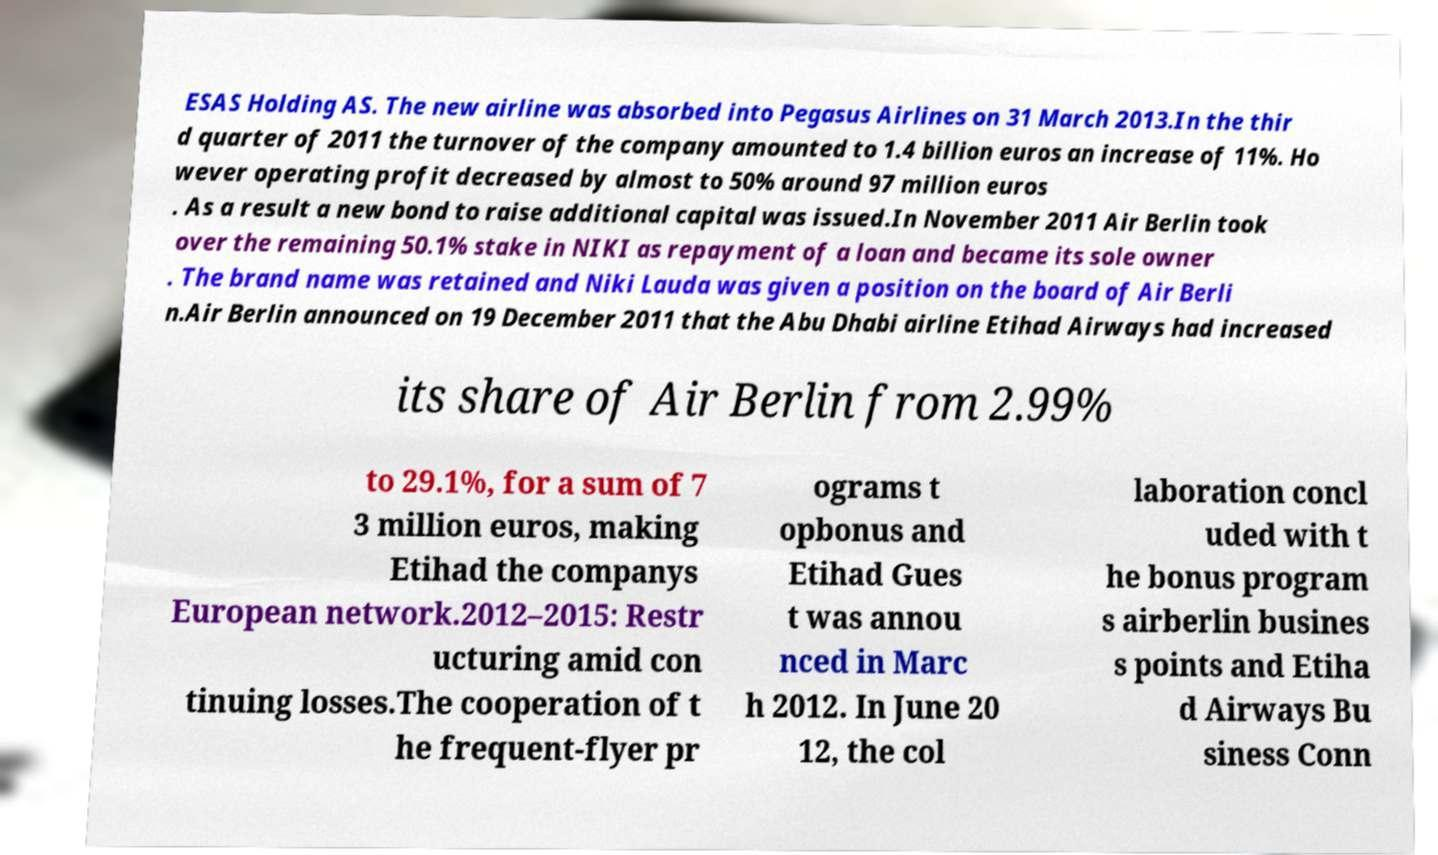For documentation purposes, I need the text within this image transcribed. Could you provide that? ESAS Holding AS. The new airline was absorbed into Pegasus Airlines on 31 March 2013.In the thir d quarter of 2011 the turnover of the company amounted to 1.4 billion euros an increase of 11%. Ho wever operating profit decreased by almost to 50% around 97 million euros . As a result a new bond to raise additional capital was issued.In November 2011 Air Berlin took over the remaining 50.1% stake in NIKI as repayment of a loan and became its sole owner . The brand name was retained and Niki Lauda was given a position on the board of Air Berli n.Air Berlin announced on 19 December 2011 that the Abu Dhabi airline Etihad Airways had increased its share of Air Berlin from 2.99% to 29.1%, for a sum of 7 3 million euros, making Etihad the companys European network.2012–2015: Restr ucturing amid con tinuing losses.The cooperation of t he frequent-flyer pr ograms t opbonus and Etihad Gues t was annou nced in Marc h 2012. In June 20 12, the col laboration concl uded with t he bonus program s airberlin busines s points and Etiha d Airways Bu siness Conn 